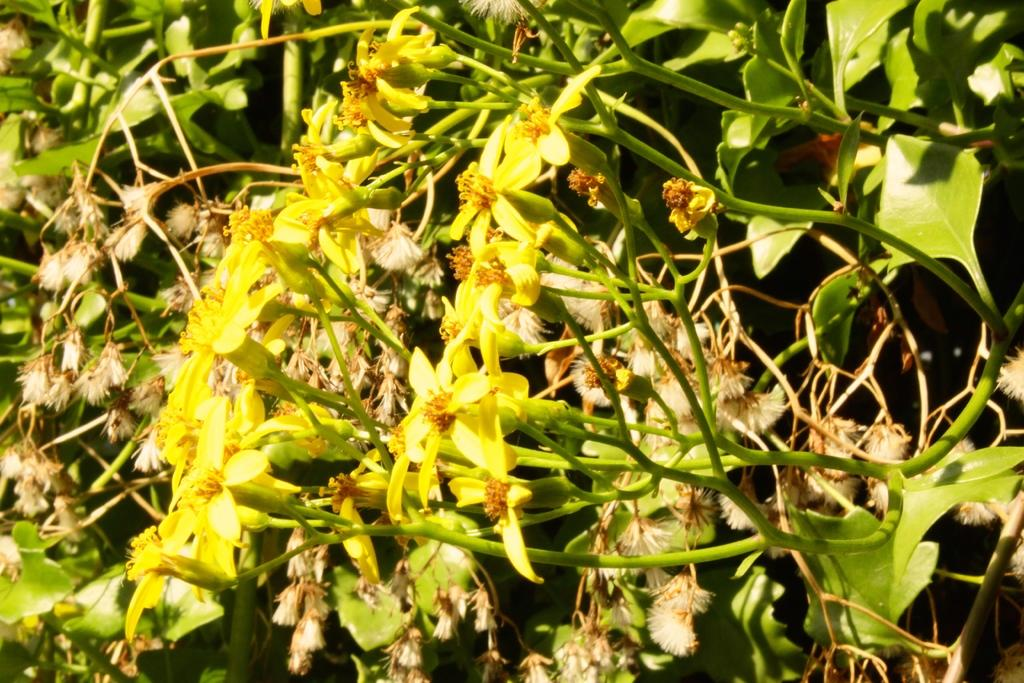What type of living organisms can be seen in the image? Plants and flowers are visible in the image. What color are the flowers in the image? The flowers in the image are yellow in color. What is the purpose of the nose in the image? There is no nose present in the image, as it features plants and flowers. 